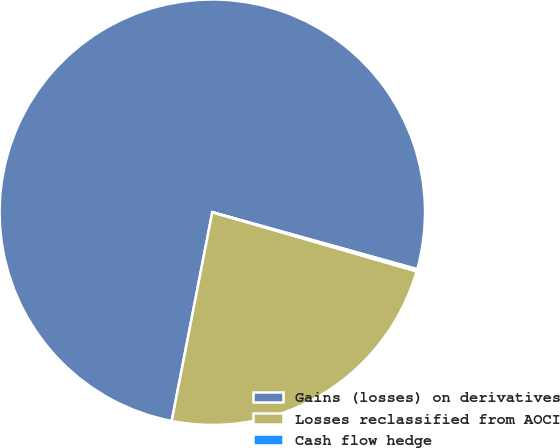Convert chart. <chart><loc_0><loc_0><loc_500><loc_500><pie_chart><fcel>Gains (losses) on derivatives<fcel>Losses reclassified from AOCI<fcel>Cash flow hedge<nl><fcel>76.26%<fcel>23.57%<fcel>0.17%<nl></chart> 